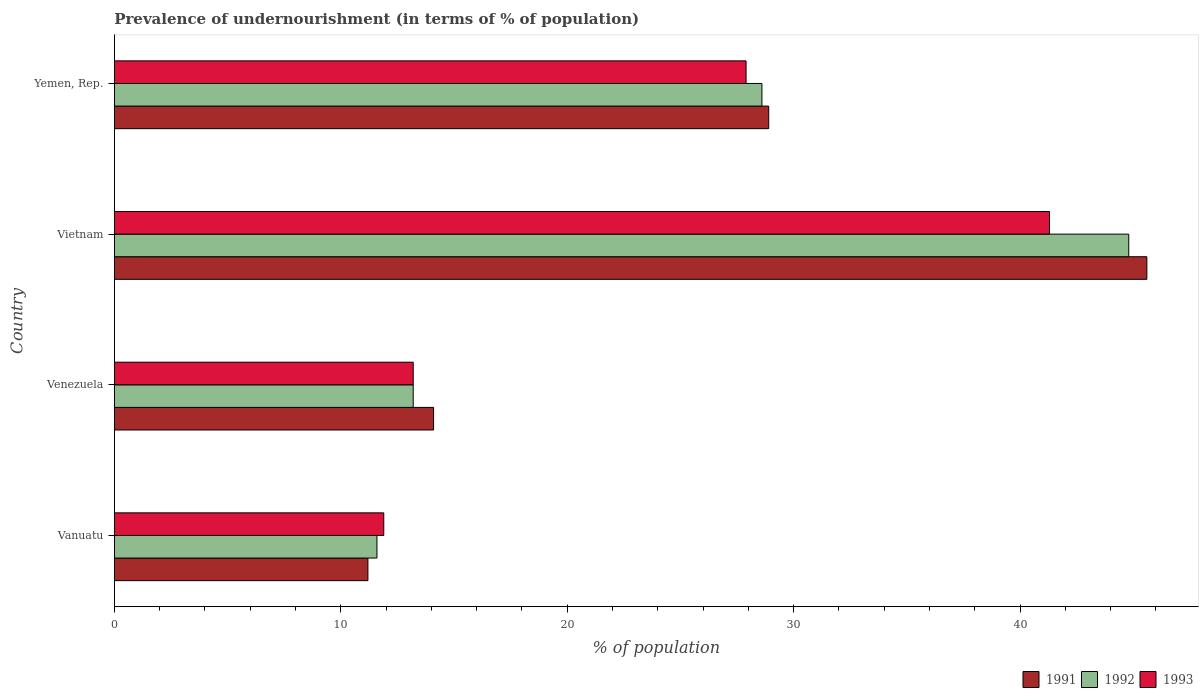How many groups of bars are there?
Provide a succinct answer. 4. Are the number of bars on each tick of the Y-axis equal?
Offer a terse response. Yes. How many bars are there on the 4th tick from the top?
Your answer should be very brief. 3. How many bars are there on the 4th tick from the bottom?
Keep it short and to the point. 3. What is the label of the 2nd group of bars from the top?
Your answer should be compact. Vietnam. What is the percentage of undernourished population in 1992 in Vanuatu?
Offer a terse response. 11.6. Across all countries, what is the maximum percentage of undernourished population in 1991?
Offer a terse response. 45.6. Across all countries, what is the minimum percentage of undernourished population in 1992?
Give a very brief answer. 11.6. In which country was the percentage of undernourished population in 1991 maximum?
Provide a short and direct response. Vietnam. In which country was the percentage of undernourished population in 1992 minimum?
Give a very brief answer. Vanuatu. What is the total percentage of undernourished population in 1992 in the graph?
Offer a very short reply. 98.2. What is the difference between the percentage of undernourished population in 1993 in Venezuela and that in Vietnam?
Provide a short and direct response. -28.1. What is the difference between the percentage of undernourished population in 1992 in Yemen, Rep. and the percentage of undernourished population in 1993 in Venezuela?
Make the answer very short. 15.4. What is the average percentage of undernourished population in 1991 per country?
Your response must be concise. 24.95. What is the difference between the percentage of undernourished population in 1993 and percentage of undernourished population in 1992 in Vanuatu?
Provide a short and direct response. 0.3. In how many countries, is the percentage of undernourished population in 1992 greater than 38 %?
Make the answer very short. 1. What is the ratio of the percentage of undernourished population in 1993 in Venezuela to that in Yemen, Rep.?
Provide a short and direct response. 0.47. Is the difference between the percentage of undernourished population in 1993 in Vanuatu and Vietnam greater than the difference between the percentage of undernourished population in 1992 in Vanuatu and Vietnam?
Provide a short and direct response. Yes. What is the difference between the highest and the second highest percentage of undernourished population in 1992?
Give a very brief answer. 16.2. What is the difference between the highest and the lowest percentage of undernourished population in 1993?
Provide a short and direct response. 29.4. In how many countries, is the percentage of undernourished population in 1991 greater than the average percentage of undernourished population in 1991 taken over all countries?
Offer a terse response. 2. What does the 3rd bar from the top in Vietnam represents?
Make the answer very short. 1991. How many bars are there?
Keep it short and to the point. 12. What is the difference between two consecutive major ticks on the X-axis?
Give a very brief answer. 10. Where does the legend appear in the graph?
Ensure brevity in your answer.  Bottom right. How many legend labels are there?
Offer a very short reply. 3. How are the legend labels stacked?
Offer a very short reply. Horizontal. What is the title of the graph?
Your response must be concise. Prevalence of undernourishment (in terms of % of population). Does "1963" appear as one of the legend labels in the graph?
Your response must be concise. No. What is the label or title of the X-axis?
Give a very brief answer. % of population. What is the label or title of the Y-axis?
Make the answer very short. Country. What is the % of population of 1991 in Vanuatu?
Keep it short and to the point. 11.2. What is the % of population in 1992 in Vanuatu?
Give a very brief answer. 11.6. What is the % of population in 1993 in Vanuatu?
Provide a short and direct response. 11.9. What is the % of population of 1993 in Venezuela?
Ensure brevity in your answer.  13.2. What is the % of population of 1991 in Vietnam?
Give a very brief answer. 45.6. What is the % of population in 1992 in Vietnam?
Your answer should be very brief. 44.8. What is the % of population in 1993 in Vietnam?
Ensure brevity in your answer.  41.3. What is the % of population of 1991 in Yemen, Rep.?
Your response must be concise. 28.9. What is the % of population in 1992 in Yemen, Rep.?
Your answer should be very brief. 28.6. What is the % of population of 1993 in Yemen, Rep.?
Your answer should be very brief. 27.9. Across all countries, what is the maximum % of population in 1991?
Offer a very short reply. 45.6. Across all countries, what is the maximum % of population of 1992?
Provide a short and direct response. 44.8. Across all countries, what is the maximum % of population of 1993?
Offer a very short reply. 41.3. What is the total % of population of 1991 in the graph?
Your answer should be compact. 99.8. What is the total % of population of 1992 in the graph?
Your answer should be very brief. 98.2. What is the total % of population of 1993 in the graph?
Provide a succinct answer. 94.3. What is the difference between the % of population in 1991 in Vanuatu and that in Venezuela?
Provide a succinct answer. -2.9. What is the difference between the % of population of 1992 in Vanuatu and that in Venezuela?
Offer a terse response. -1.6. What is the difference between the % of population of 1993 in Vanuatu and that in Venezuela?
Offer a terse response. -1.3. What is the difference between the % of population of 1991 in Vanuatu and that in Vietnam?
Provide a succinct answer. -34.4. What is the difference between the % of population of 1992 in Vanuatu and that in Vietnam?
Ensure brevity in your answer.  -33.2. What is the difference between the % of population of 1993 in Vanuatu and that in Vietnam?
Provide a succinct answer. -29.4. What is the difference between the % of population in 1991 in Vanuatu and that in Yemen, Rep.?
Offer a very short reply. -17.7. What is the difference between the % of population of 1992 in Vanuatu and that in Yemen, Rep.?
Make the answer very short. -17. What is the difference between the % of population in 1991 in Venezuela and that in Vietnam?
Keep it short and to the point. -31.5. What is the difference between the % of population of 1992 in Venezuela and that in Vietnam?
Make the answer very short. -31.6. What is the difference between the % of population of 1993 in Venezuela and that in Vietnam?
Your answer should be compact. -28.1. What is the difference between the % of population of 1991 in Venezuela and that in Yemen, Rep.?
Offer a terse response. -14.8. What is the difference between the % of population in 1992 in Venezuela and that in Yemen, Rep.?
Your response must be concise. -15.4. What is the difference between the % of population of 1993 in Venezuela and that in Yemen, Rep.?
Make the answer very short. -14.7. What is the difference between the % of population of 1991 in Vietnam and that in Yemen, Rep.?
Keep it short and to the point. 16.7. What is the difference between the % of population of 1993 in Vietnam and that in Yemen, Rep.?
Ensure brevity in your answer.  13.4. What is the difference between the % of population in 1991 in Vanuatu and the % of population in 1993 in Venezuela?
Ensure brevity in your answer.  -2. What is the difference between the % of population in 1991 in Vanuatu and the % of population in 1992 in Vietnam?
Ensure brevity in your answer.  -33.6. What is the difference between the % of population in 1991 in Vanuatu and the % of population in 1993 in Vietnam?
Your answer should be compact. -30.1. What is the difference between the % of population in 1992 in Vanuatu and the % of population in 1993 in Vietnam?
Offer a terse response. -29.7. What is the difference between the % of population of 1991 in Vanuatu and the % of population of 1992 in Yemen, Rep.?
Offer a terse response. -17.4. What is the difference between the % of population of 1991 in Vanuatu and the % of population of 1993 in Yemen, Rep.?
Your answer should be very brief. -16.7. What is the difference between the % of population in 1992 in Vanuatu and the % of population in 1993 in Yemen, Rep.?
Your answer should be compact. -16.3. What is the difference between the % of population in 1991 in Venezuela and the % of population in 1992 in Vietnam?
Make the answer very short. -30.7. What is the difference between the % of population in 1991 in Venezuela and the % of population in 1993 in Vietnam?
Offer a very short reply. -27.2. What is the difference between the % of population of 1992 in Venezuela and the % of population of 1993 in Vietnam?
Your answer should be compact. -28.1. What is the difference between the % of population of 1991 in Venezuela and the % of population of 1993 in Yemen, Rep.?
Your answer should be compact. -13.8. What is the difference between the % of population of 1992 in Venezuela and the % of population of 1993 in Yemen, Rep.?
Provide a succinct answer. -14.7. What is the difference between the % of population of 1991 in Vietnam and the % of population of 1993 in Yemen, Rep.?
Keep it short and to the point. 17.7. What is the average % of population of 1991 per country?
Make the answer very short. 24.95. What is the average % of population of 1992 per country?
Give a very brief answer. 24.55. What is the average % of population in 1993 per country?
Your answer should be very brief. 23.57. What is the difference between the % of population in 1991 and % of population in 1993 in Vanuatu?
Your answer should be compact. -0.7. What is the difference between the % of population in 1991 and % of population in 1992 in Venezuela?
Provide a short and direct response. 0.9. What is the difference between the % of population of 1991 and % of population of 1993 in Venezuela?
Your response must be concise. 0.9. What is the difference between the % of population in 1992 and % of population in 1993 in Vietnam?
Offer a terse response. 3.5. What is the ratio of the % of population in 1991 in Vanuatu to that in Venezuela?
Offer a very short reply. 0.79. What is the ratio of the % of population in 1992 in Vanuatu to that in Venezuela?
Give a very brief answer. 0.88. What is the ratio of the % of population in 1993 in Vanuatu to that in Venezuela?
Offer a very short reply. 0.9. What is the ratio of the % of population of 1991 in Vanuatu to that in Vietnam?
Your answer should be very brief. 0.25. What is the ratio of the % of population in 1992 in Vanuatu to that in Vietnam?
Provide a succinct answer. 0.26. What is the ratio of the % of population in 1993 in Vanuatu to that in Vietnam?
Provide a succinct answer. 0.29. What is the ratio of the % of population in 1991 in Vanuatu to that in Yemen, Rep.?
Your answer should be very brief. 0.39. What is the ratio of the % of population in 1992 in Vanuatu to that in Yemen, Rep.?
Your answer should be compact. 0.41. What is the ratio of the % of population of 1993 in Vanuatu to that in Yemen, Rep.?
Provide a short and direct response. 0.43. What is the ratio of the % of population of 1991 in Venezuela to that in Vietnam?
Provide a succinct answer. 0.31. What is the ratio of the % of population in 1992 in Venezuela to that in Vietnam?
Provide a succinct answer. 0.29. What is the ratio of the % of population in 1993 in Venezuela to that in Vietnam?
Ensure brevity in your answer.  0.32. What is the ratio of the % of population of 1991 in Venezuela to that in Yemen, Rep.?
Provide a succinct answer. 0.49. What is the ratio of the % of population of 1992 in Venezuela to that in Yemen, Rep.?
Offer a very short reply. 0.46. What is the ratio of the % of population of 1993 in Venezuela to that in Yemen, Rep.?
Provide a short and direct response. 0.47. What is the ratio of the % of population of 1991 in Vietnam to that in Yemen, Rep.?
Provide a succinct answer. 1.58. What is the ratio of the % of population of 1992 in Vietnam to that in Yemen, Rep.?
Offer a terse response. 1.57. What is the ratio of the % of population of 1993 in Vietnam to that in Yemen, Rep.?
Offer a terse response. 1.48. What is the difference between the highest and the second highest % of population in 1991?
Make the answer very short. 16.7. What is the difference between the highest and the second highest % of population of 1992?
Ensure brevity in your answer.  16.2. What is the difference between the highest and the lowest % of population in 1991?
Provide a succinct answer. 34.4. What is the difference between the highest and the lowest % of population of 1992?
Provide a short and direct response. 33.2. What is the difference between the highest and the lowest % of population of 1993?
Give a very brief answer. 29.4. 